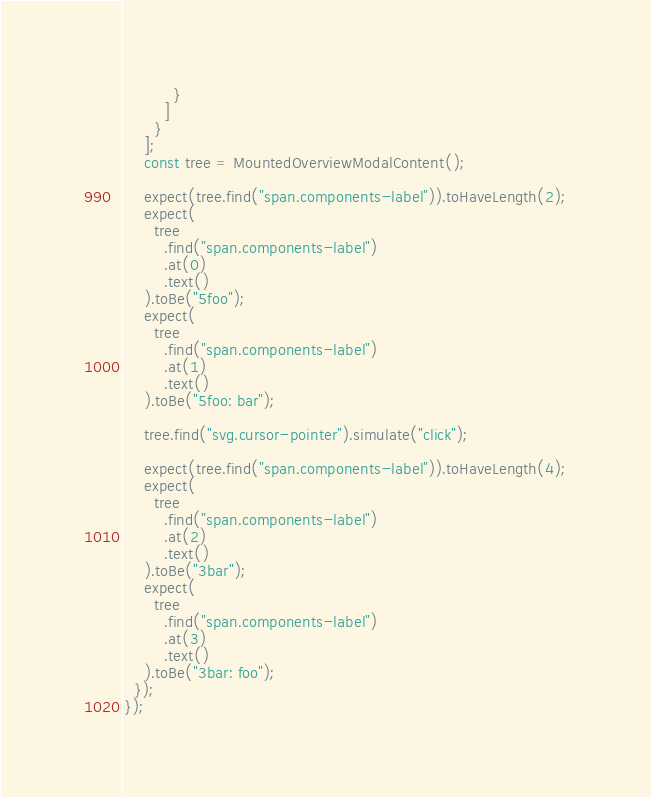<code> <loc_0><loc_0><loc_500><loc_500><_JavaScript_>          }
        ]
      }
    ];
    const tree = MountedOverviewModalContent();

    expect(tree.find("span.components-label")).toHaveLength(2);
    expect(
      tree
        .find("span.components-label")
        .at(0)
        .text()
    ).toBe("5foo");
    expect(
      tree
        .find("span.components-label")
        .at(1)
        .text()
    ).toBe("5foo: bar");

    tree.find("svg.cursor-pointer").simulate("click");

    expect(tree.find("span.components-label")).toHaveLength(4);
    expect(
      tree
        .find("span.components-label")
        .at(2)
        .text()
    ).toBe("3bar");
    expect(
      tree
        .find("span.components-label")
        .at(3)
        .text()
    ).toBe("3bar: foo");
  });
});
</code> 